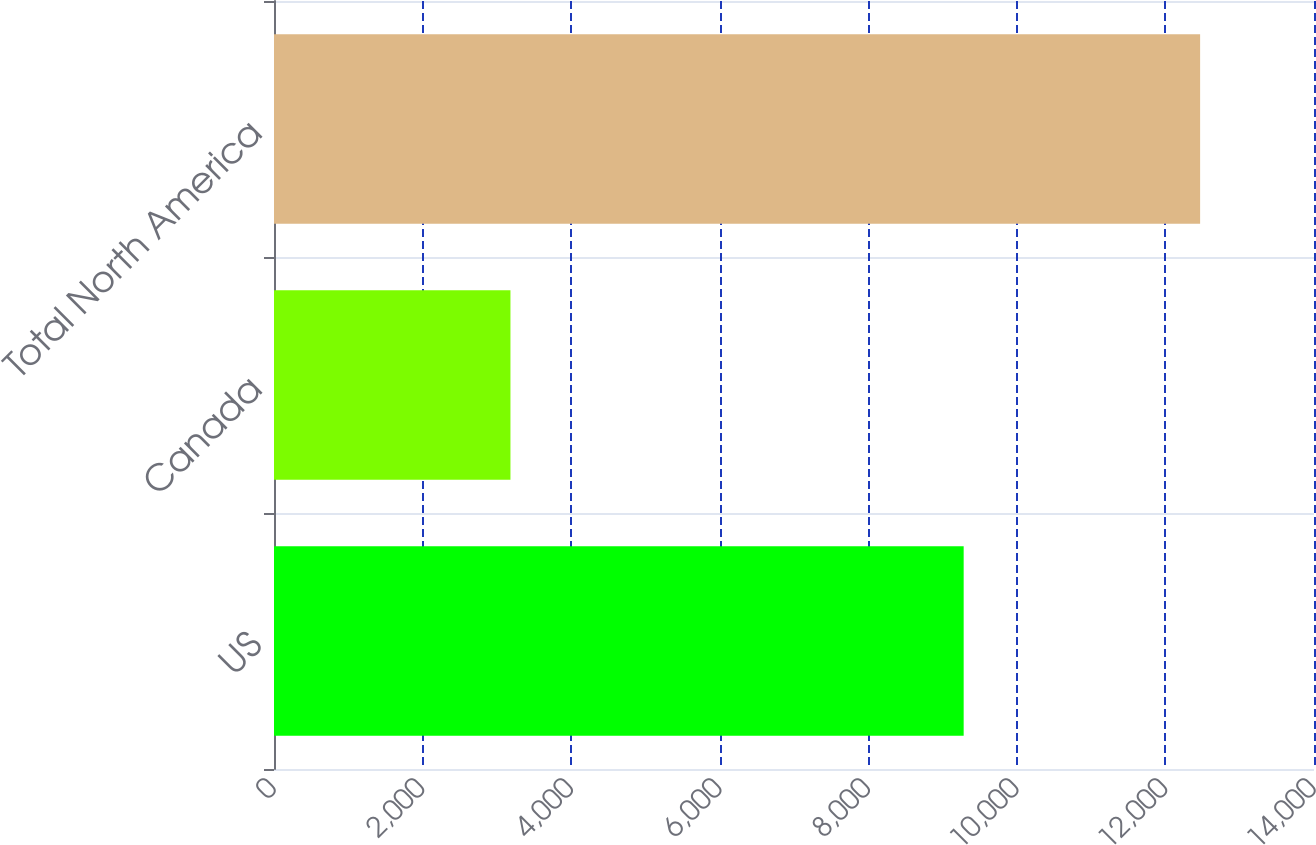Convert chart to OTSL. <chart><loc_0><loc_0><loc_500><loc_500><bar_chart><fcel>US<fcel>Canada<fcel>Total North America<nl><fcel>9284<fcel>3183<fcel>12467<nl></chart> 